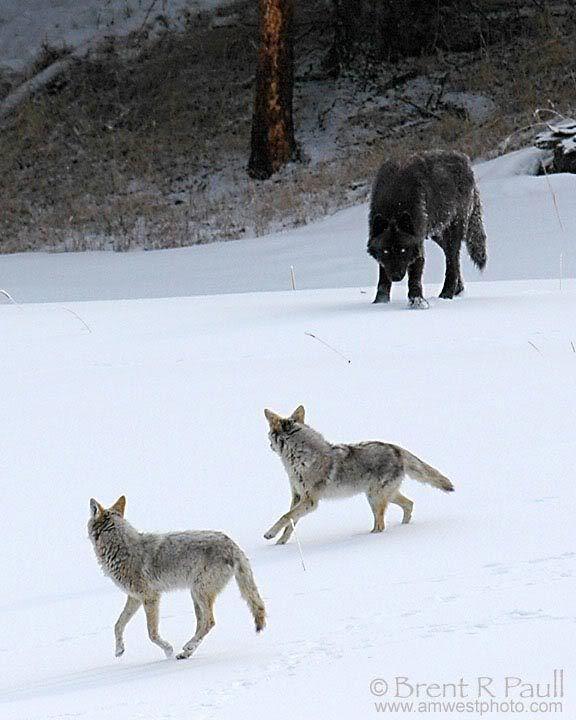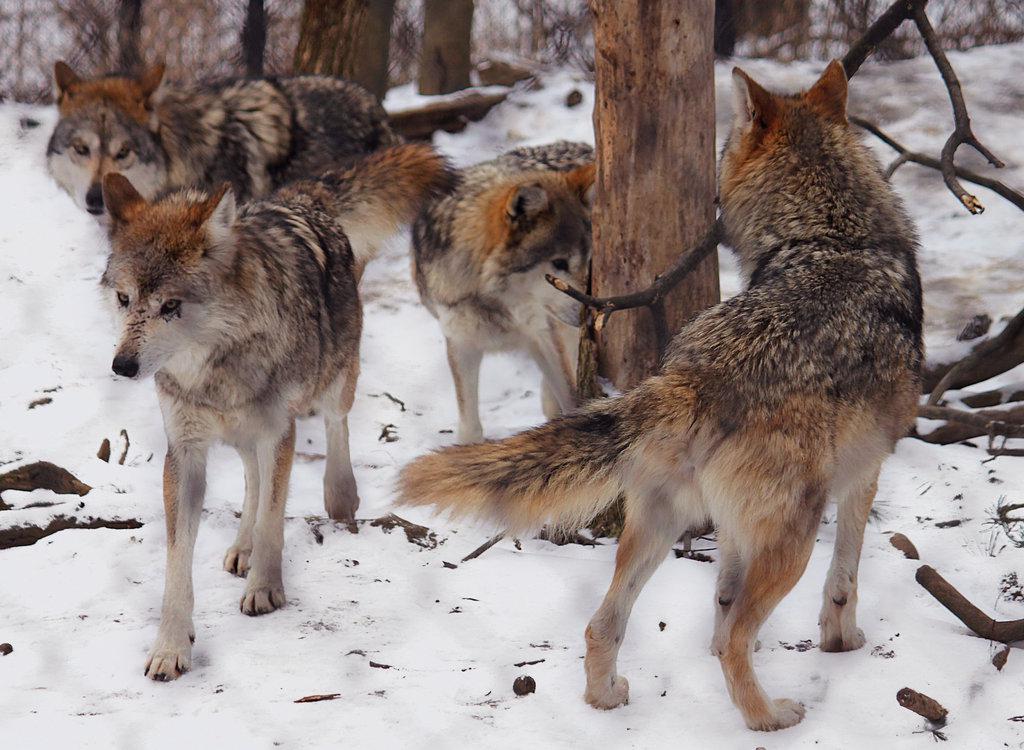The first image is the image on the left, the second image is the image on the right. For the images shown, is this caption "An image shows at least four wolves posed right by a large upright tree trunk." true? Answer yes or no. Yes. The first image is the image on the left, the second image is the image on the right. For the images shown, is this caption "Some of the dogs are howling with their heads pointed up." true? Answer yes or no. No. 